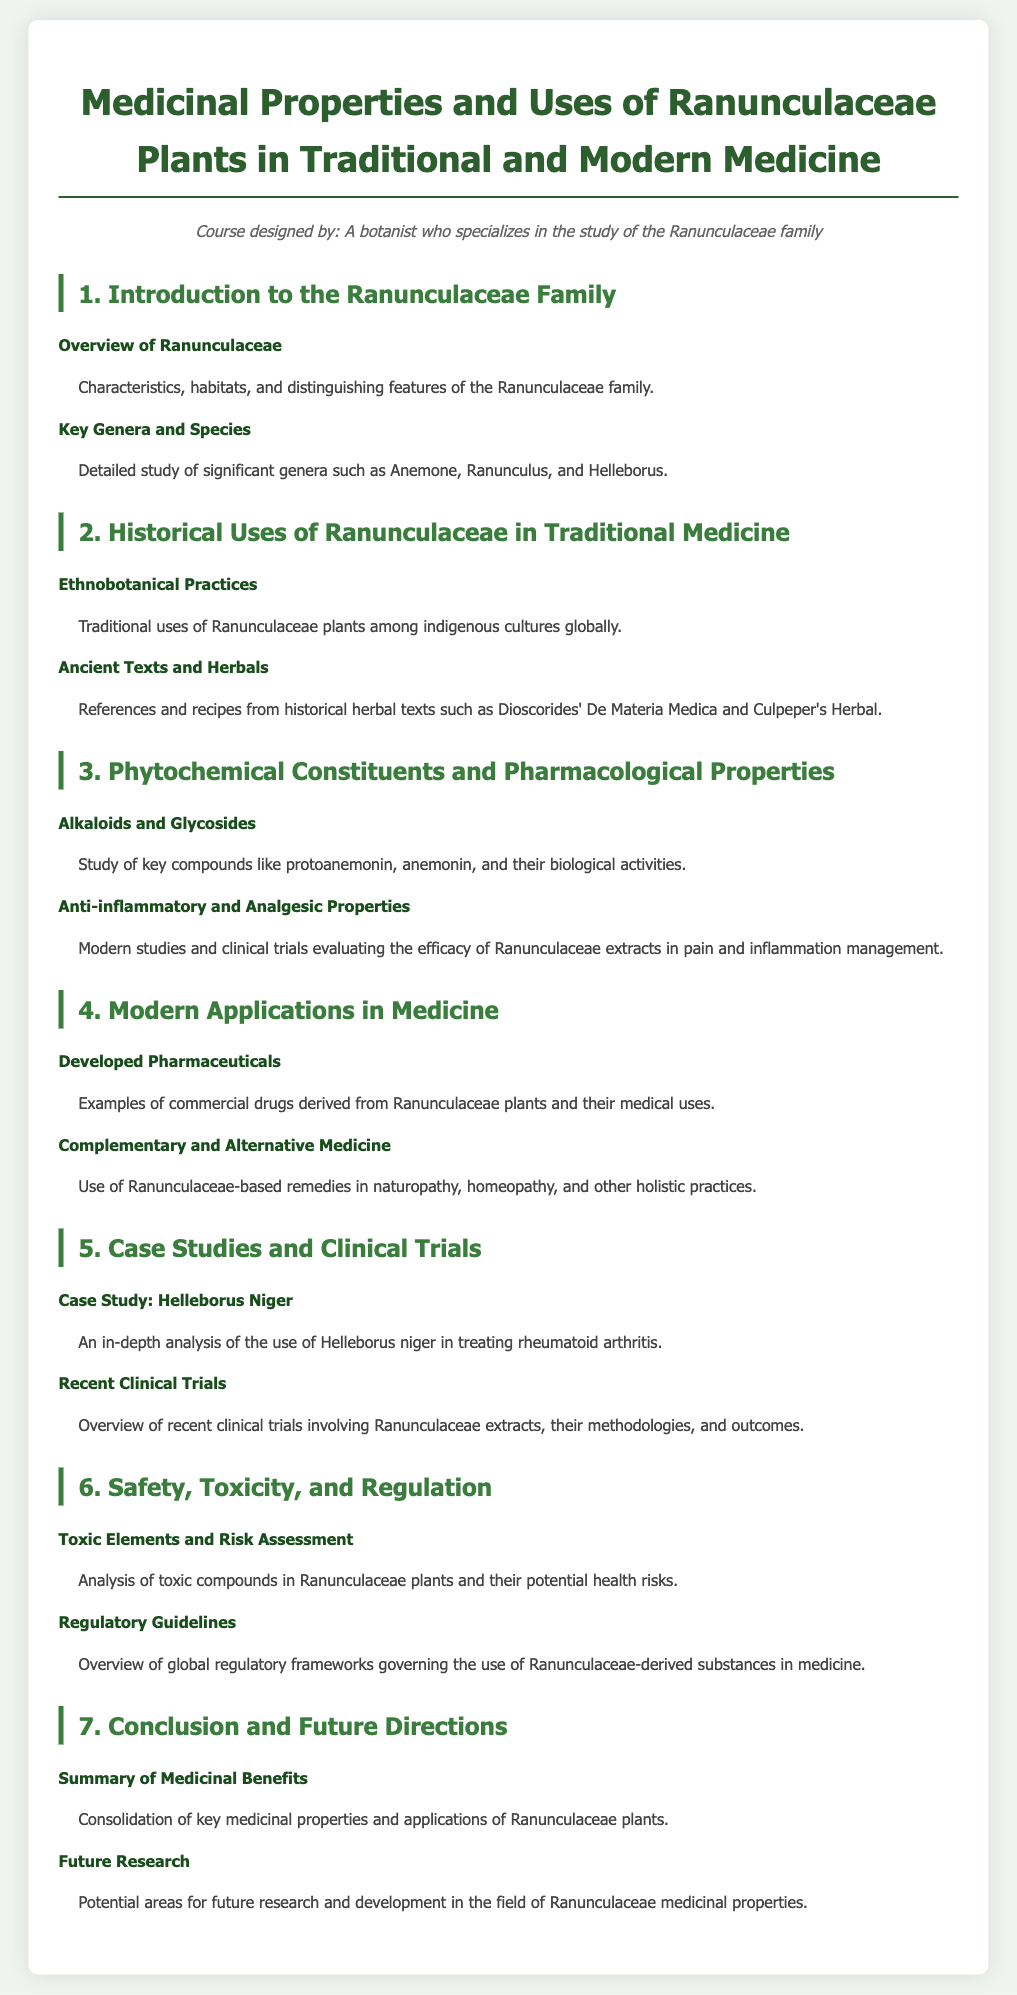What are the key genera studied in this syllabus? The document outlines a detailed study of significant genera such as Anemone, Ranunculus, and Helleborus.
Answer: Anemone, Ranunculus, Helleborus What is the title of the first section in the syllabus? The first section, as indicated in the syllabus, is "1. Introduction to the Ranunculaceae Family."
Answer: 1. Introduction to the Ranunculaceae Family Which plant is analyzed in detail regarding rheumatoid arthritis treatment? The document highlights Helleborus niger as a case study for treating rheumatoid arthritis.
Answer: Helleborus niger What are the major alkaloids discussed in the syllabus? Key compounds mentioned include protoanemonin and anemonin, which are noted for their biological activities.
Answer: protoanemonin, anemonin What is one of the uses of Ranunculaceae plants in complementary medicine? The syllabus states that Ranunculaceae-based remedies are used in naturopathy, homeopathy, and other holistic practices.
Answer: naturopathy, homeopathy, holistic practices What does the document say about regulatory guidelines? It provides an overview of global regulatory frameworks governing the use of Ranunculaceae-derived substances in medicine.
Answer: global regulatory frameworks What section covers historical uses of Ranunculaceae? The second section titled "2. Historical Uses of Ranunculaceae in Traditional Medicine" addresses this topic.
Answer: 2. Historical Uses of Ranunculaceae in Traditional Medicine 